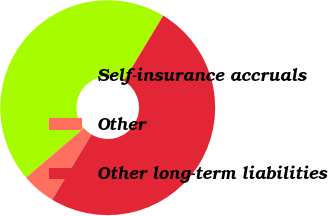<chart> <loc_0><loc_0><loc_500><loc_500><pie_chart><fcel>Self-insurance accruals<fcel>Other<fcel>Other long-term liabilities<nl><fcel>44.92%<fcel>5.08%<fcel>50.0%<nl></chart> 